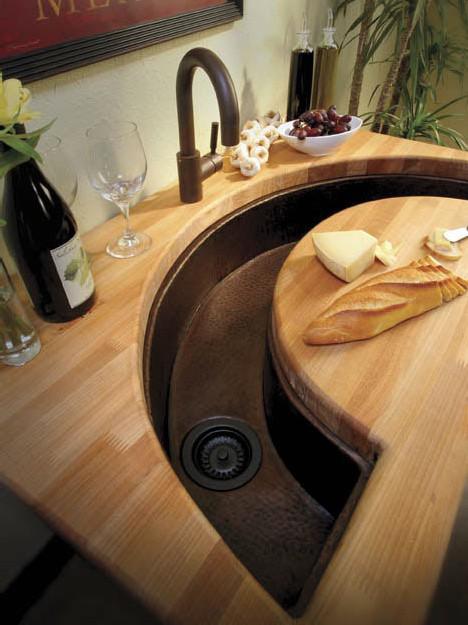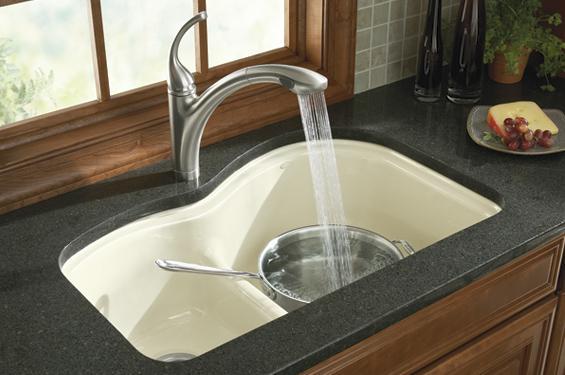The first image is the image on the left, the second image is the image on the right. Examine the images to the left and right. Is the description "Water is coming out of one of the faucets." accurate? Answer yes or no. Yes. The first image is the image on the left, the second image is the image on the right. Assess this claim about the two images: "Water is running from a faucet in one of the images.". Correct or not? Answer yes or no. Yes. 